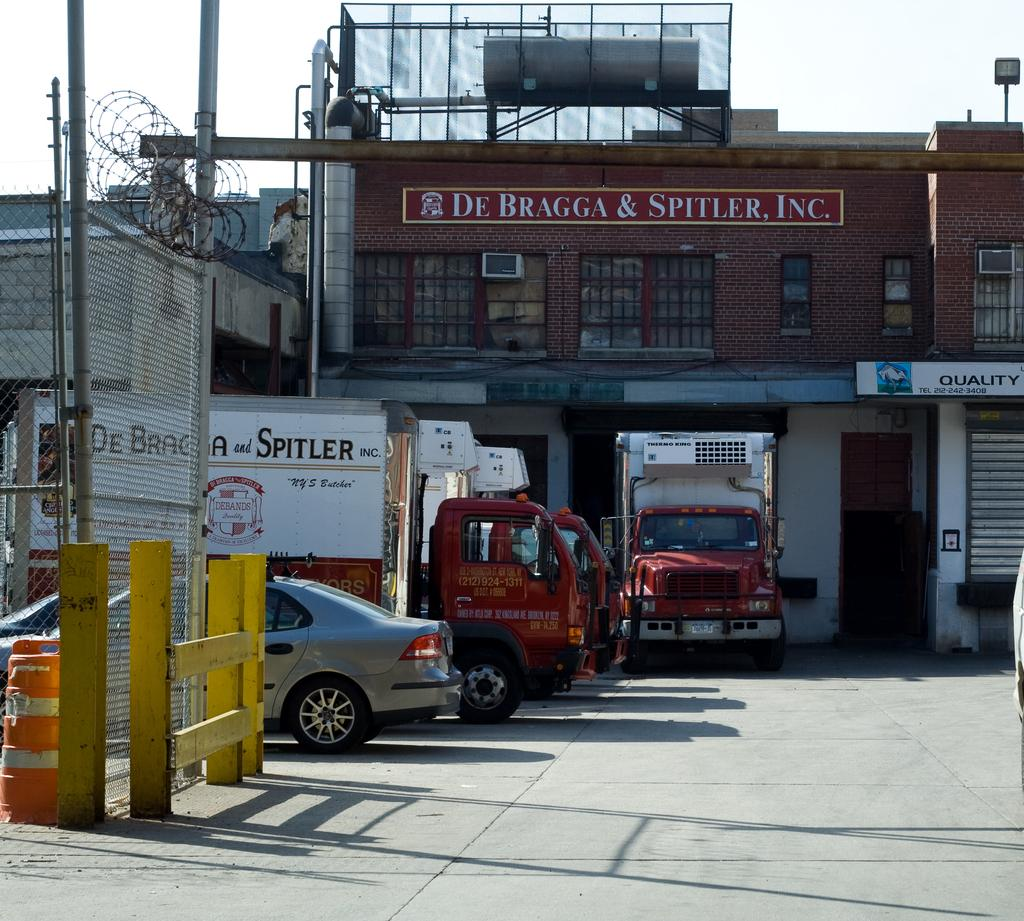<image>
Share a concise interpretation of the image provided. De Bragga & Spittler, Inc. has their own fleet of trucks with their name and information painted on the side and dock doors for easy loading of those trucks. 